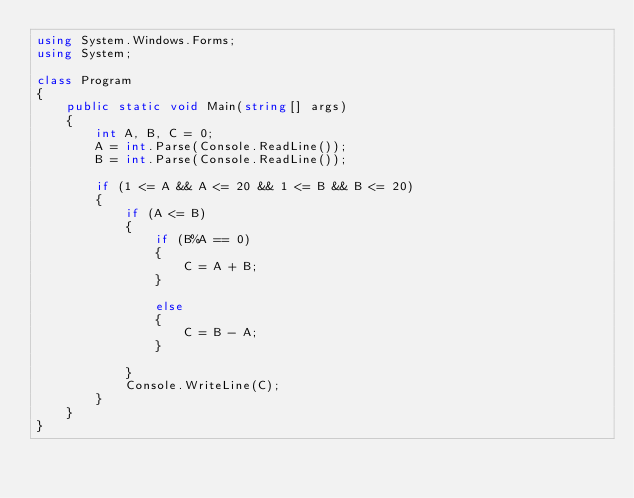<code> <loc_0><loc_0><loc_500><loc_500><_C#_>using System.Windows.Forms;
using System;

class Program
{
	public static void Main(string[] args)
	{
		int A, B, C = 0;
		A = int.Parse(Console.ReadLine());
		B = int.Parse(Console.ReadLine());

		if (1 <= A && A <= 20 && 1 <= B && B <= 20)
		{
			if (A <= B)
			{
				if (B%A == 0)
				{
					C = A + B;
				}

				else
				{
					C = B - A; 
				}

			}
			Console.WriteLine(C);
		}
	}
}</code> 